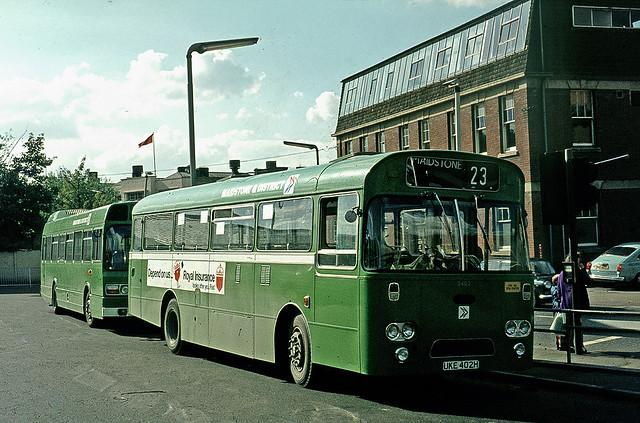What is the sum of each individual digit on the top of the bus? five 